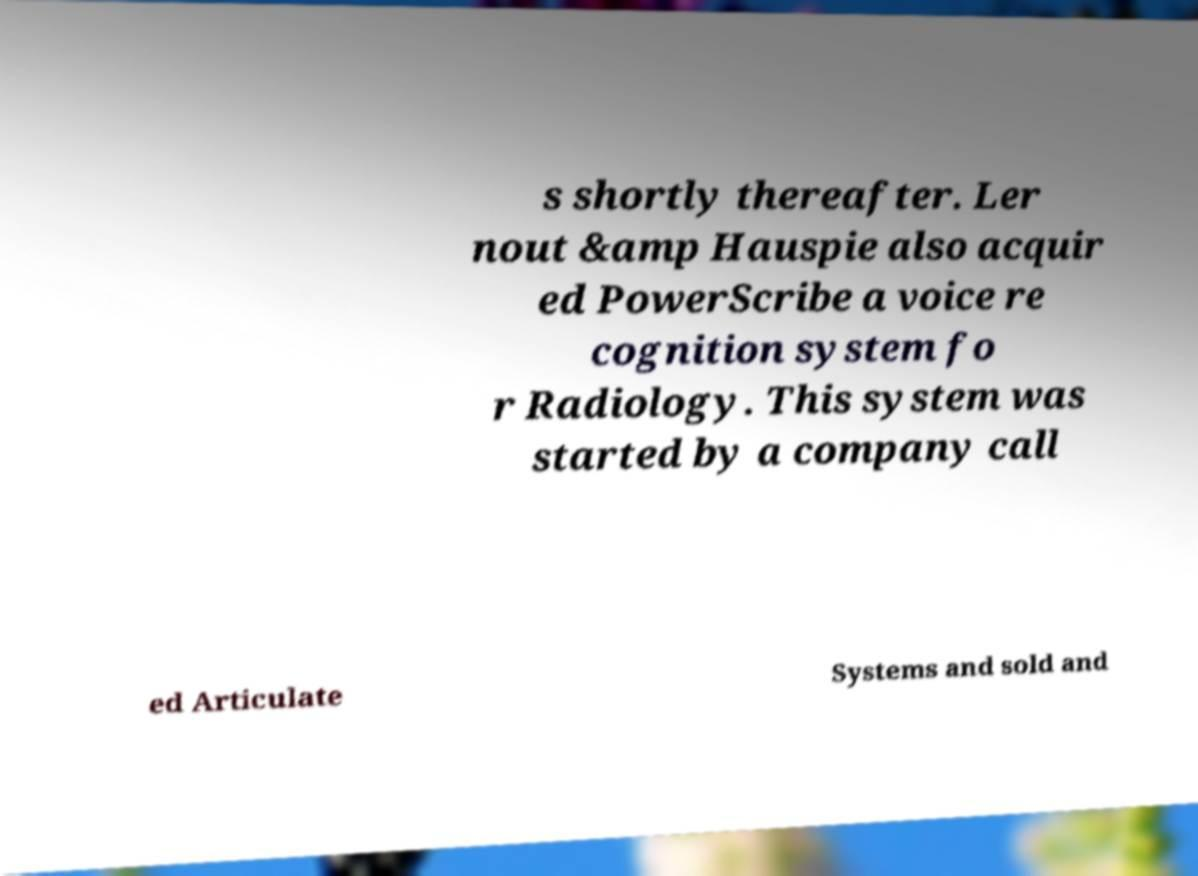Please read and relay the text visible in this image. What does it say? s shortly thereafter. Ler nout &amp Hauspie also acquir ed PowerScribe a voice re cognition system fo r Radiology. This system was started by a company call ed Articulate Systems and sold and 